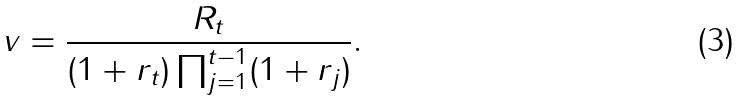Convert formula to latex. <formula><loc_0><loc_0><loc_500><loc_500>v = \frac { R _ { t } } { ( 1 + r _ { t } ) \prod _ { j = 1 } ^ { t - 1 } ( 1 + r _ { j } ) } .</formula> 